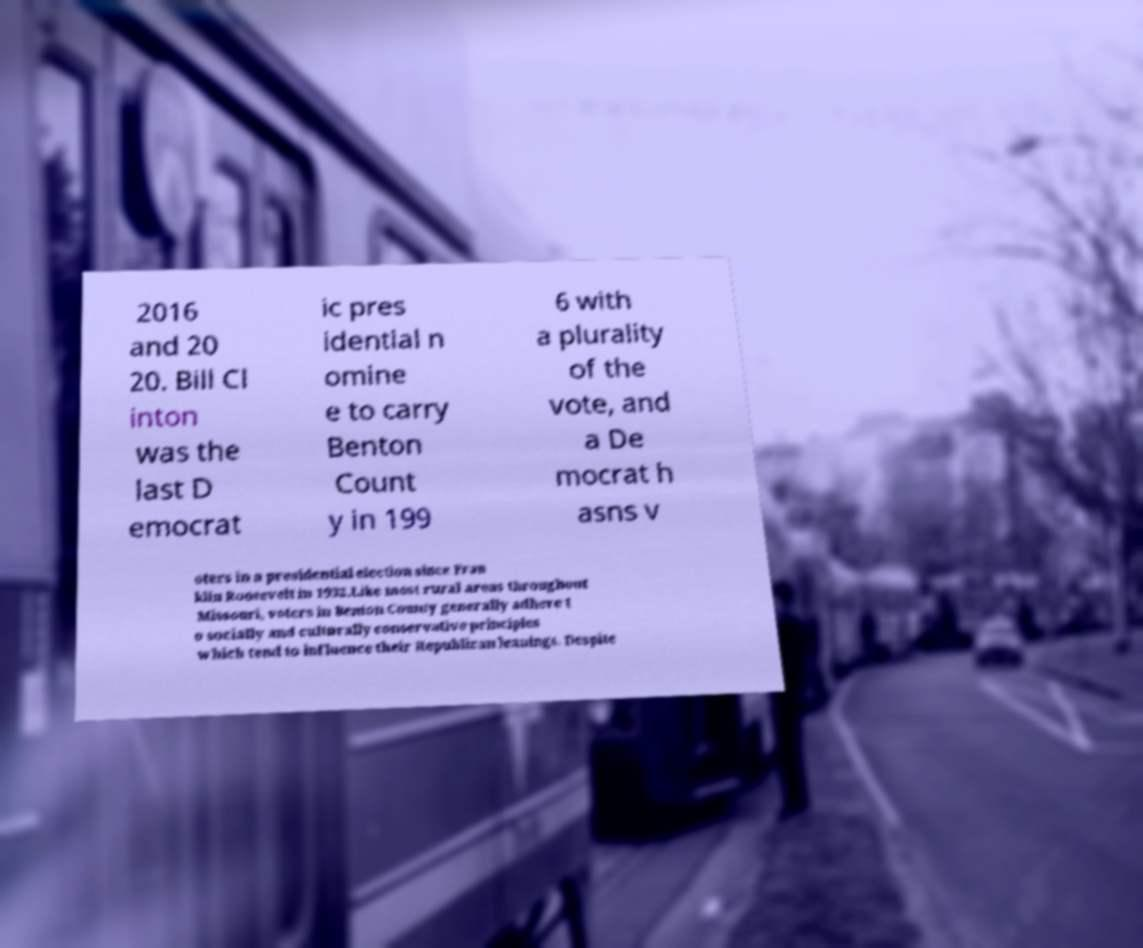For documentation purposes, I need the text within this image transcribed. Could you provide that? 2016 and 20 20. Bill Cl inton was the last D emocrat ic pres idential n omine e to carry Benton Count y in 199 6 with a plurality of the vote, and a De mocrat h asns v oters in a presidential election since Fran klin Roosevelt in 1932.Like most rural areas throughout Missouri, voters in Benton County generally adhere t o socially and culturally conservative principles which tend to influence their Republican leanings. Despite 